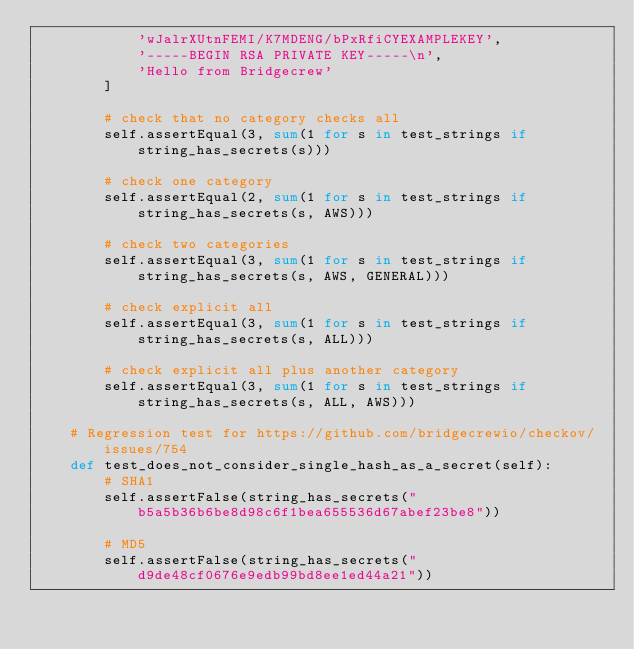<code> <loc_0><loc_0><loc_500><loc_500><_Python_>            'wJalrXUtnFEMI/K7MDENG/bPxRfiCYEXAMPLEKEY',
            '-----BEGIN RSA PRIVATE KEY-----\n',
            'Hello from Bridgecrew'
        ]

        # check that no category checks all
        self.assertEqual(3, sum(1 for s in test_strings if string_has_secrets(s)))

        # check one category
        self.assertEqual(2, sum(1 for s in test_strings if string_has_secrets(s, AWS)))

        # check two categories
        self.assertEqual(3, sum(1 for s in test_strings if string_has_secrets(s, AWS, GENERAL)))

        # check explicit all
        self.assertEqual(3, sum(1 for s in test_strings if string_has_secrets(s, ALL)))

        # check explicit all plus another category
        self.assertEqual(3, sum(1 for s in test_strings if string_has_secrets(s, ALL, AWS)))

    # Regression test for https://github.com/bridgecrewio/checkov/issues/754
    def test_does_not_consider_single_hash_as_a_secret(self):
        # SHA1
        self.assertFalse(string_has_secrets("b5a5b36b6be8d98c6f1bea655536d67abef23be8"))

        # MD5
        self.assertFalse(string_has_secrets("d9de48cf0676e9edb99bd8ee1ed44a21"))
</code> 